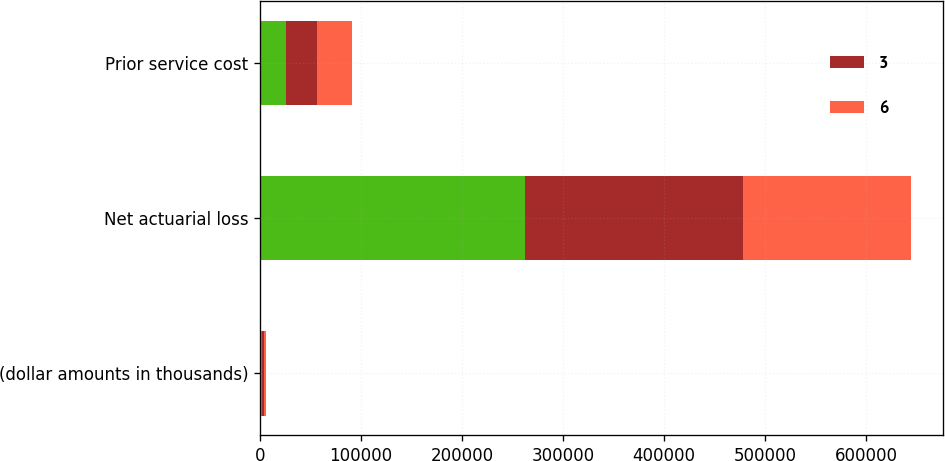<chart> <loc_0><loc_0><loc_500><loc_500><stacked_bar_chart><ecel><fcel>(dollar amounts in thousands)<fcel>Net actuarial loss<fcel>Prior service cost<nl><fcel>nan<fcel>2012<fcel>262187<fcel>25788<nl><fcel>3<fcel>2011<fcel>215628<fcel>30261<nl><fcel>6<fcel>2010<fcel>166183<fcel>34688<nl></chart> 